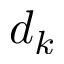<formula> <loc_0><loc_0><loc_500><loc_500>d _ { k }</formula> 